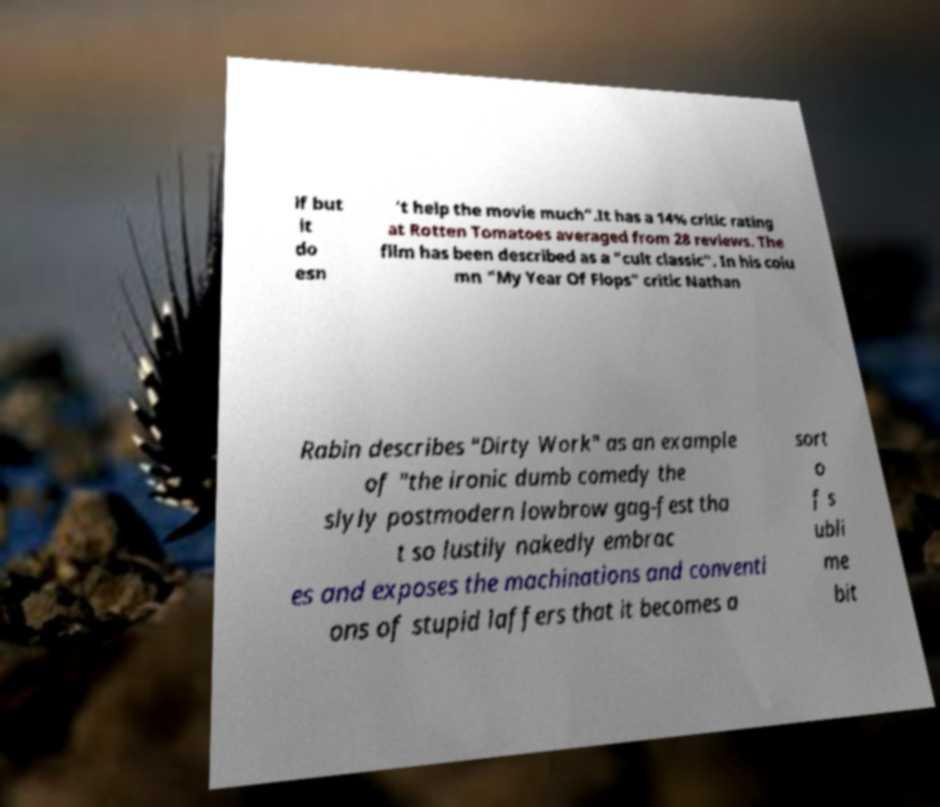Please identify and transcribe the text found in this image. lf but it do esn 't help the movie much".It has a 14% critic rating at Rotten Tomatoes averaged from 28 reviews. The film has been described as a "cult classic". In his colu mn "My Year Of Flops" critic Nathan Rabin describes "Dirty Work" as an example of "the ironic dumb comedy the slyly postmodern lowbrow gag-fest tha t so lustily nakedly embrac es and exposes the machinations and conventi ons of stupid laffers that it becomes a sort o f s ubli me bit 